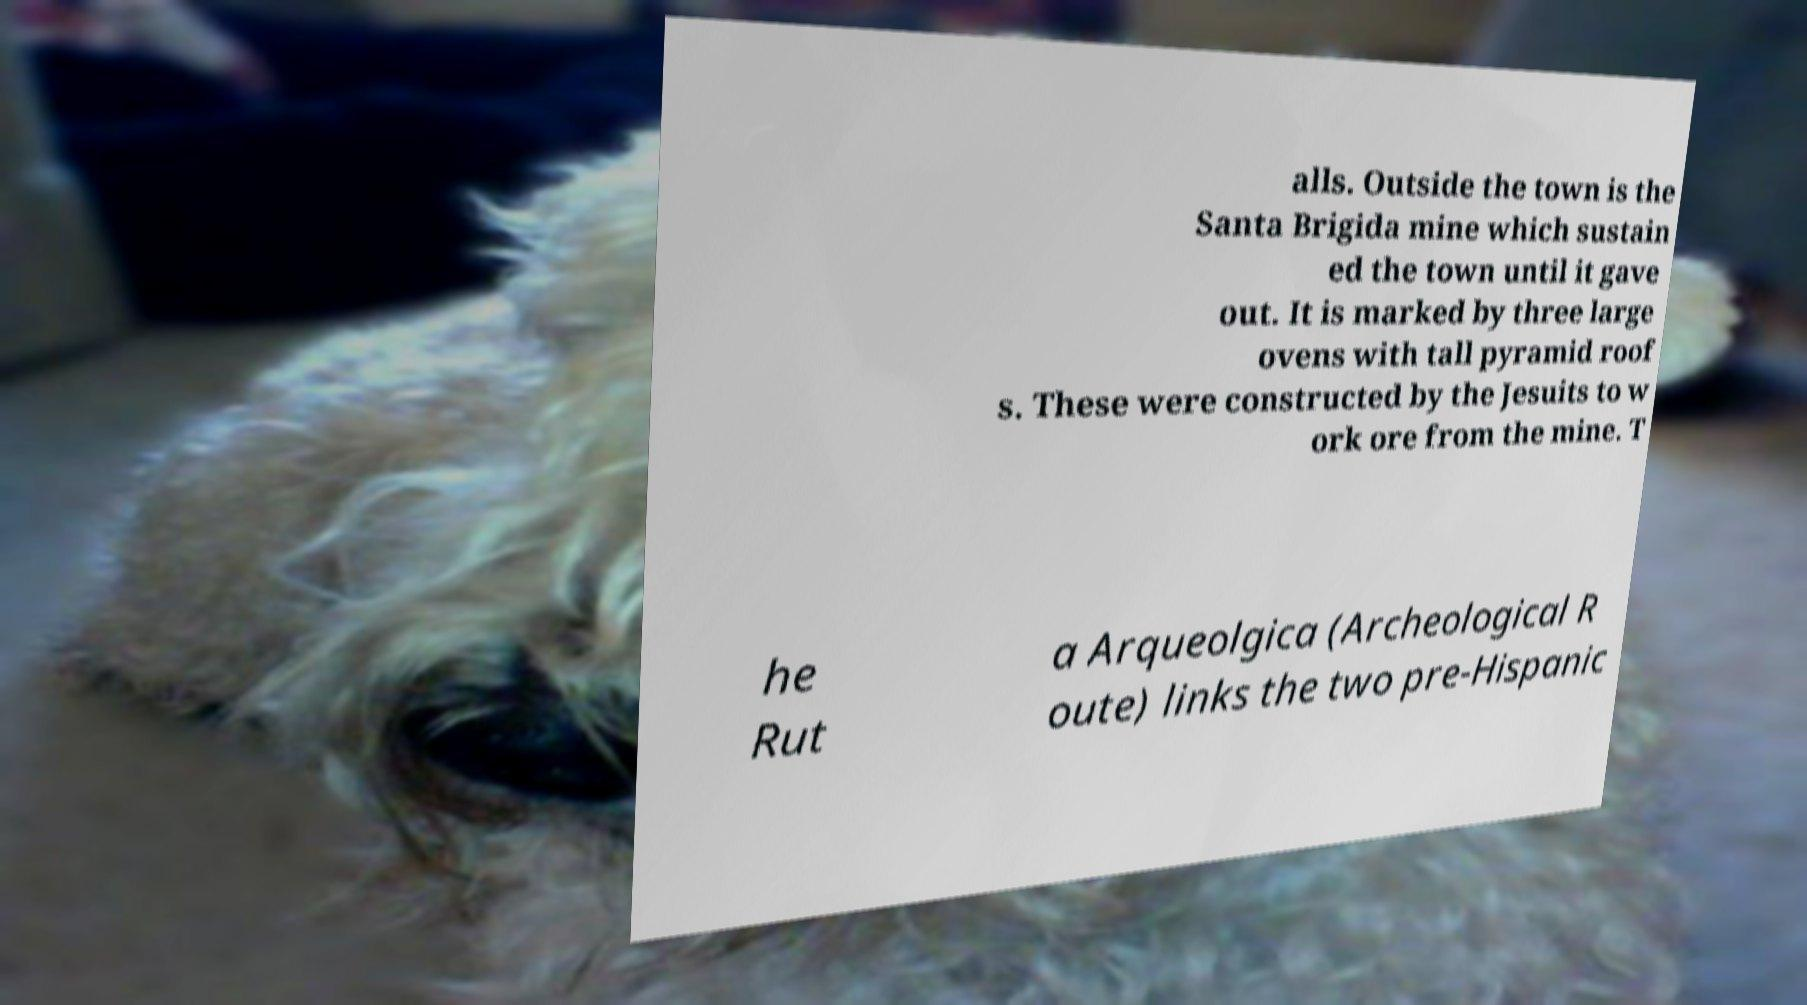Please read and relay the text visible in this image. What does it say? alls. Outside the town is the Santa Brigida mine which sustain ed the town until it gave out. It is marked by three large ovens with tall pyramid roof s. These were constructed by the Jesuits to w ork ore from the mine. T he Rut a Arqueolgica (Archeological R oute) links the two pre-Hispanic 